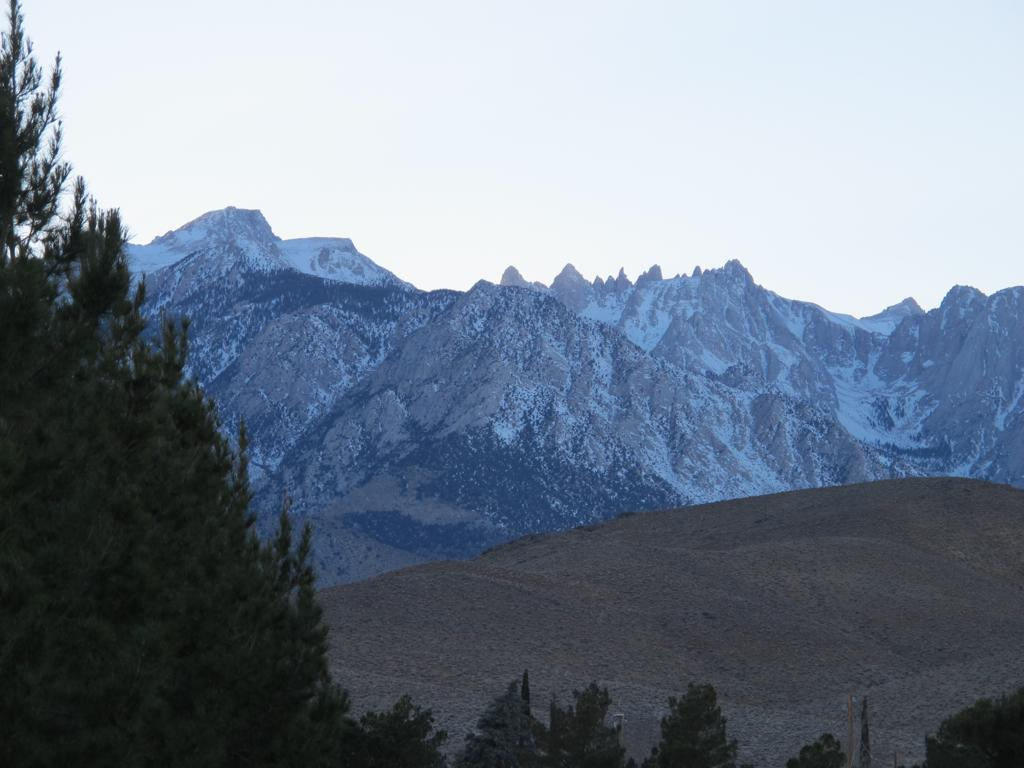What type of vegetation is at the bottom of the image? There are trees at the bottom of the image. What geographical feature is visible in the middle of the image? There are hills with snow in the middle of the image. What is visible at the top of the image? The sky is visible at the top of the image. What type of shoes can be seen in the image? There are no shoes present in the image. What type of pie is being served in the image? There is no pie present in the image. 